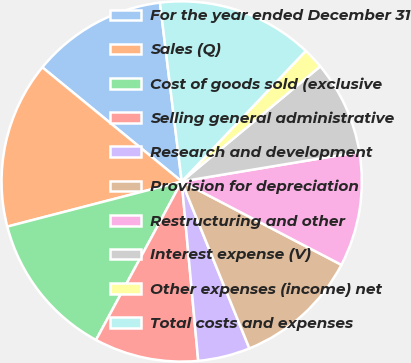Convert chart. <chart><loc_0><loc_0><loc_500><loc_500><pie_chart><fcel>For the year ended December 31<fcel>Sales (Q)<fcel>Cost of goods sold (exclusive<fcel>Selling general administrative<fcel>Research and development<fcel>Provision for depreciation<fcel>Restructuring and other<fcel>Interest expense (V)<fcel>Other expenses (income) net<fcel>Total costs and expenses<nl><fcel>12.15%<fcel>14.95%<fcel>13.08%<fcel>9.35%<fcel>4.67%<fcel>11.21%<fcel>10.28%<fcel>8.41%<fcel>1.87%<fcel>14.02%<nl></chart> 